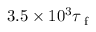Convert formula to latex. <formula><loc_0><loc_0><loc_500><loc_500>3 . 5 \times 1 0 ^ { 3 } \tau _ { f }</formula> 